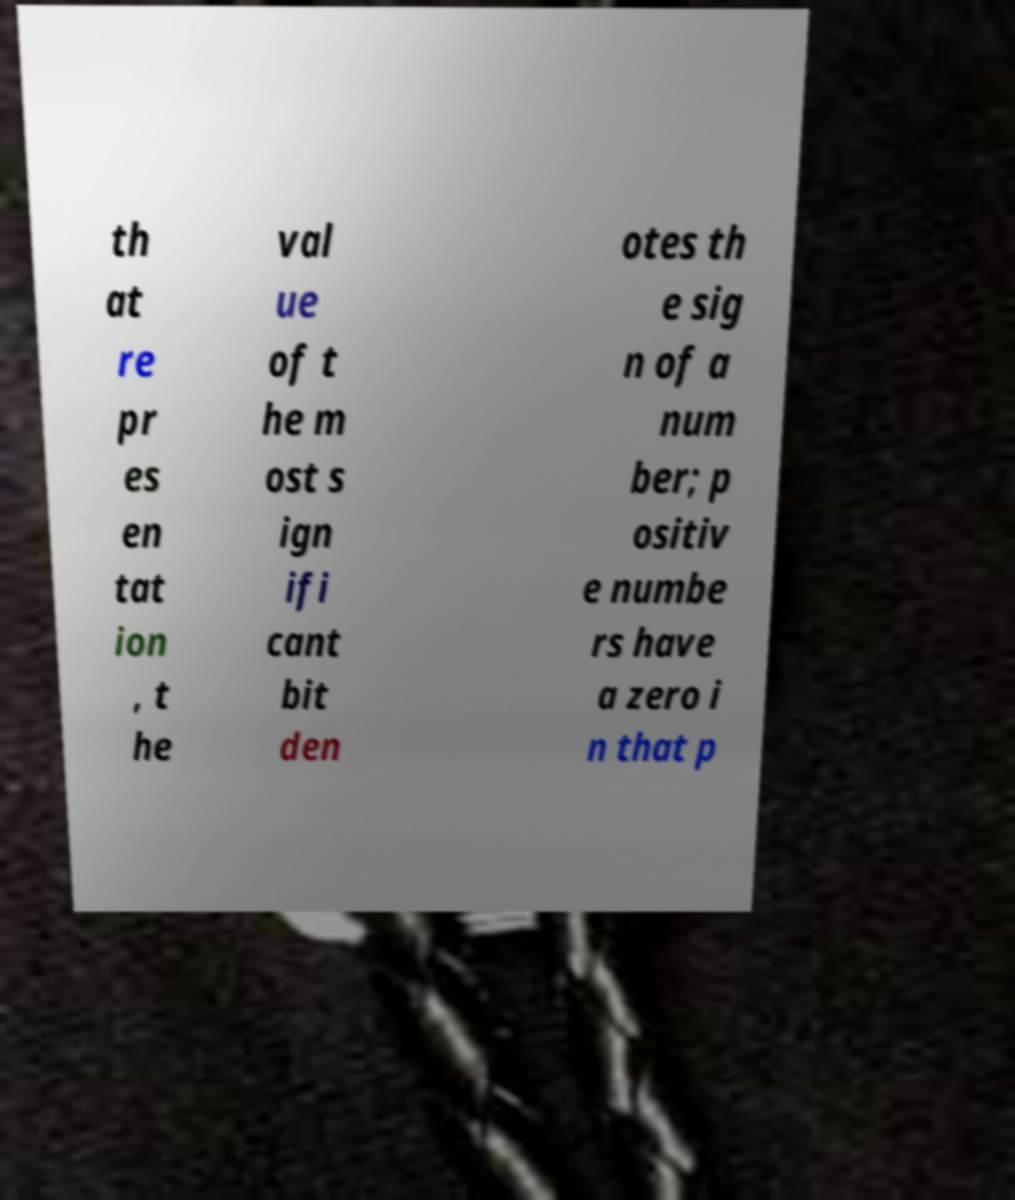Please read and relay the text visible in this image. What does it say? th at re pr es en tat ion , t he val ue of t he m ost s ign ifi cant bit den otes th e sig n of a num ber; p ositiv e numbe rs have a zero i n that p 